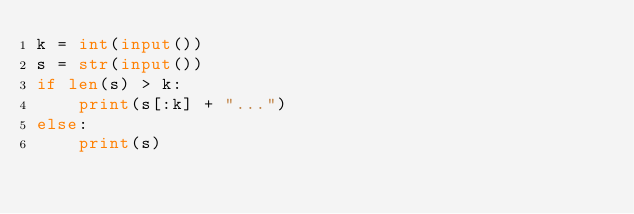<code> <loc_0><loc_0><loc_500><loc_500><_Python_>k = int(input())
s = str(input())
if len(s) > k:
    print(s[:k] + "...")
else:
    print(s)</code> 